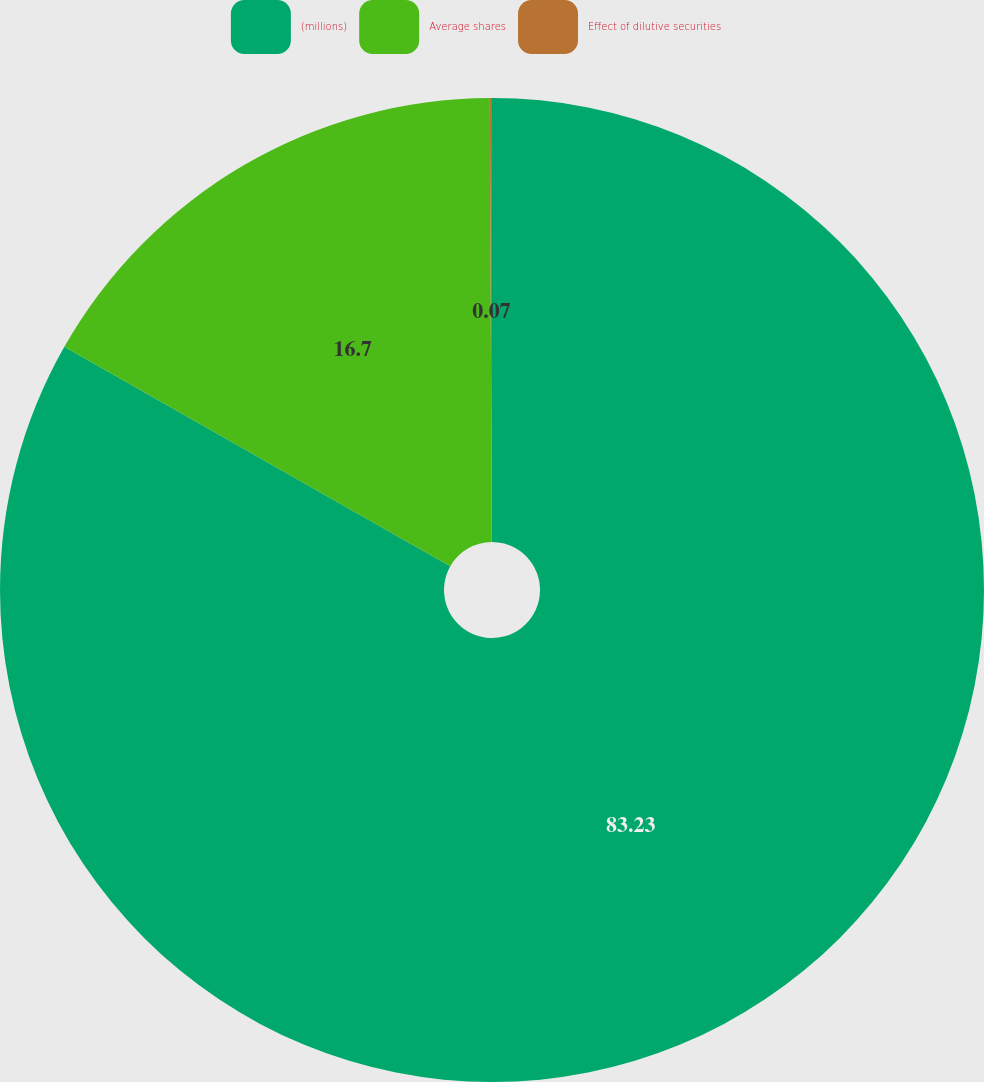Convert chart. <chart><loc_0><loc_0><loc_500><loc_500><pie_chart><fcel>(millions)<fcel>Average shares<fcel>Effect of dilutive securities<nl><fcel>83.23%<fcel>16.7%<fcel>0.07%<nl></chart> 